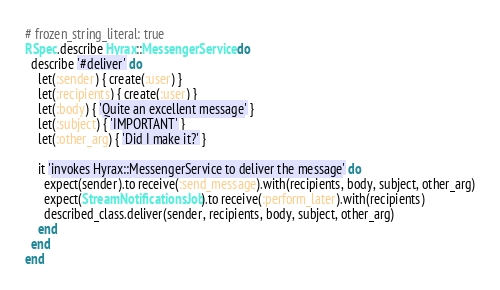Convert code to text. <code><loc_0><loc_0><loc_500><loc_500><_Ruby_># frozen_string_literal: true
RSpec.describe Hyrax::MessengerService do
  describe '#deliver' do
    let(:sender) { create(:user) }
    let(:recipients) { create(:user) }
    let(:body) { 'Quite an excellent message' }
    let(:subject) { 'IMPORTANT' }
    let(:other_arg) { 'Did I make it?' }

    it 'invokes Hyrax::MessengerService to deliver the message' do
      expect(sender).to receive(:send_message).with(recipients, body, subject, other_arg)
      expect(StreamNotificationsJob).to receive(:perform_later).with(recipients)
      described_class.deliver(sender, recipients, body, subject, other_arg)
    end
  end
end
</code> 